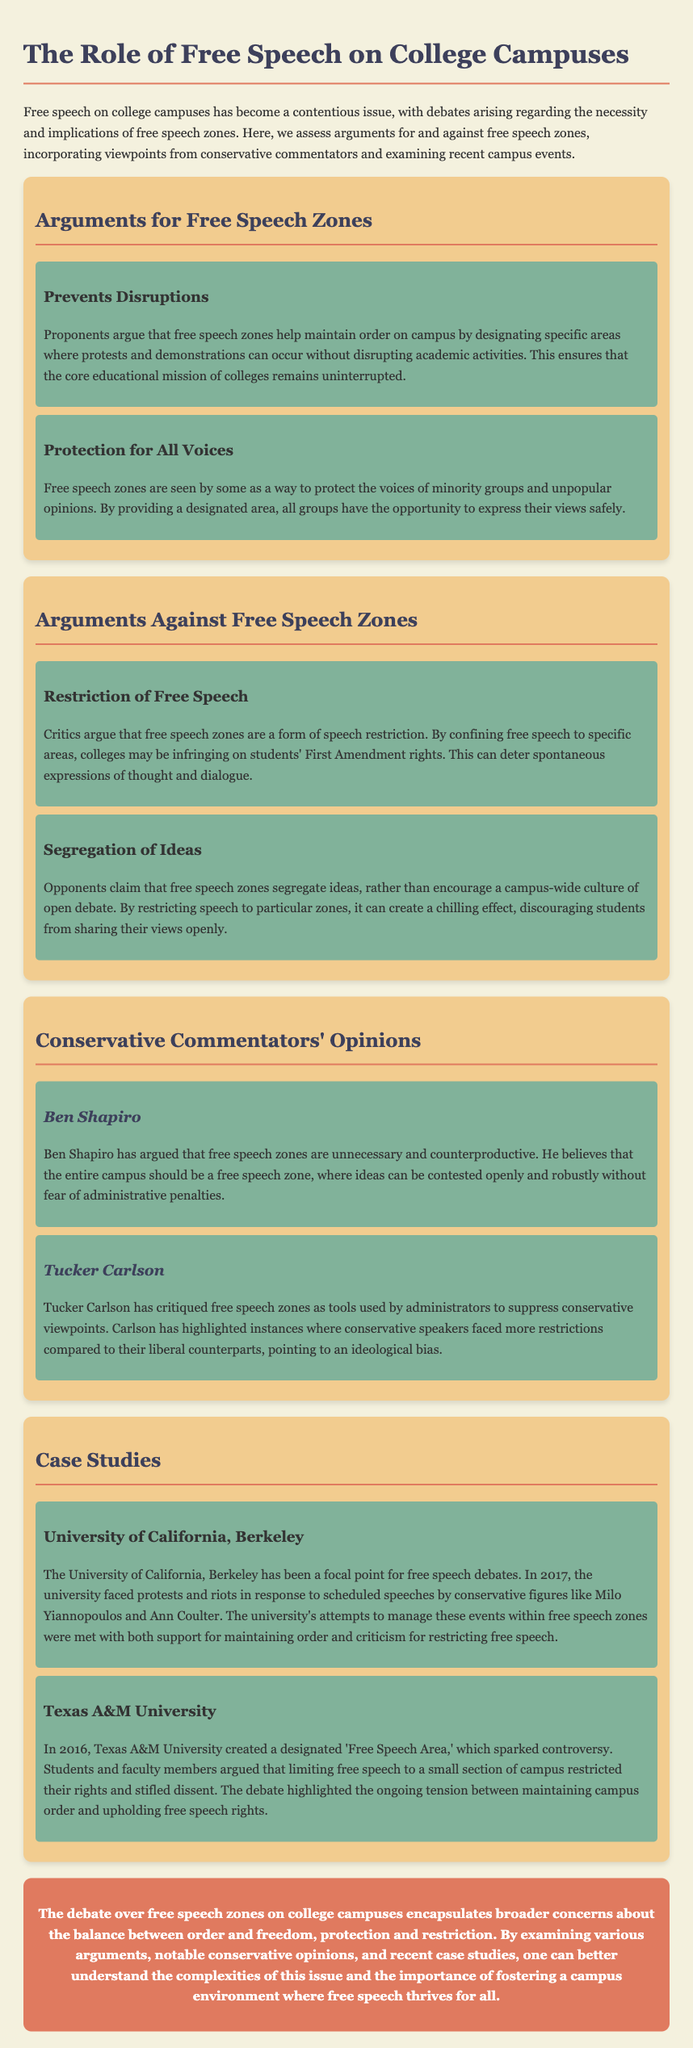What are free speech zones intended to do? The document states that proponents argue that free speech zones help maintain order on campus by designating specific areas for protests and demonstrations.
Answer: Maintain order Who argued against the necessity of free speech zones? The document mentions Ben Shapiro in the context of arguing that free speech zones are unnecessary.
Answer: Ben Shapiro What is one criticism of free speech zones mentioned in the document? The document lists that critics argue free speech zones are a form of speech restriction.
Answer: Speech restriction What year did the protests at the University of California, Berkeley occur? According to the document, the protests and riots occurred in 2017.
Answer: 2017 Which conservative commentator highlighted ideological bias in free speech zones? The document indicates that Tucker Carlson critiqued free speech zones as tools used by administrators to suppress conservative viewpoints.
Answer: Tucker Carlson What is the conclusion drawn about free speech zones on college campuses? The document concludes that the debate encapsulates broader concerns about the balance between order and freedom.
Answer: Balance between order and freedom What was a notable incident at Texas A&M University regarding free speech? The document states that Texas A&M University created a designated 'Free Speech Area' in 2016, which sparked controversy.
Answer: 'Free Speech Area' in 2016 Which conservative speakers faced protests at the University of California, Berkeley? The document mentions conservative figures like Milo Yiannopoulos and Ann Coulter.
Answer: Milo Yiannopoulos and Ann Coulter 